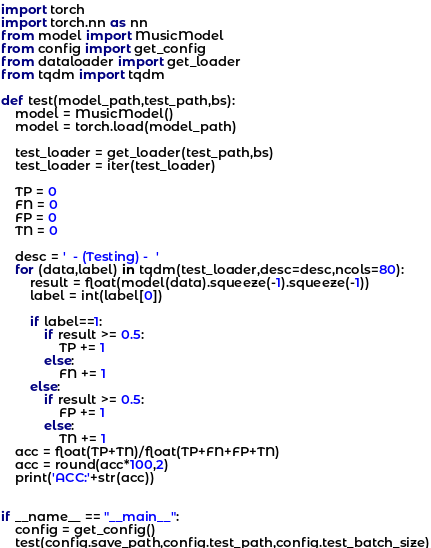<code> <loc_0><loc_0><loc_500><loc_500><_Python_>import torch
import torch.nn as nn
from model import MusicModel
from config import get_config
from dataloader import get_loader
from tqdm import tqdm

def test(model_path,test_path,bs):
    model = MusicModel()
    model = torch.load(model_path)

    test_loader = get_loader(test_path,bs)
    test_loader = iter(test_loader)

    TP = 0 
    FN = 0 
    FP = 0 
    TN = 0 

    desc = '  - (Testing) -  '
    for (data,label) in tqdm(test_loader,desc=desc,ncols=80):
        result = float(model(data).squeeze(-1).squeeze(-1))
        label = int(label[0])

        if label==1:
            if result >= 0.5:
                TP += 1
            else:
                FN += 1
        else:
            if result >= 0.5:
                FP += 1
            else:
                TN += 1
    acc = float(TP+TN)/float(TP+FN+FP+TN)
    acc = round(acc*100,2)
    print('ACC:'+str(acc))


if __name__ == "__main__":
    config = get_config()
    test(config.save_path,config.test_path,config.test_batch_size)</code> 